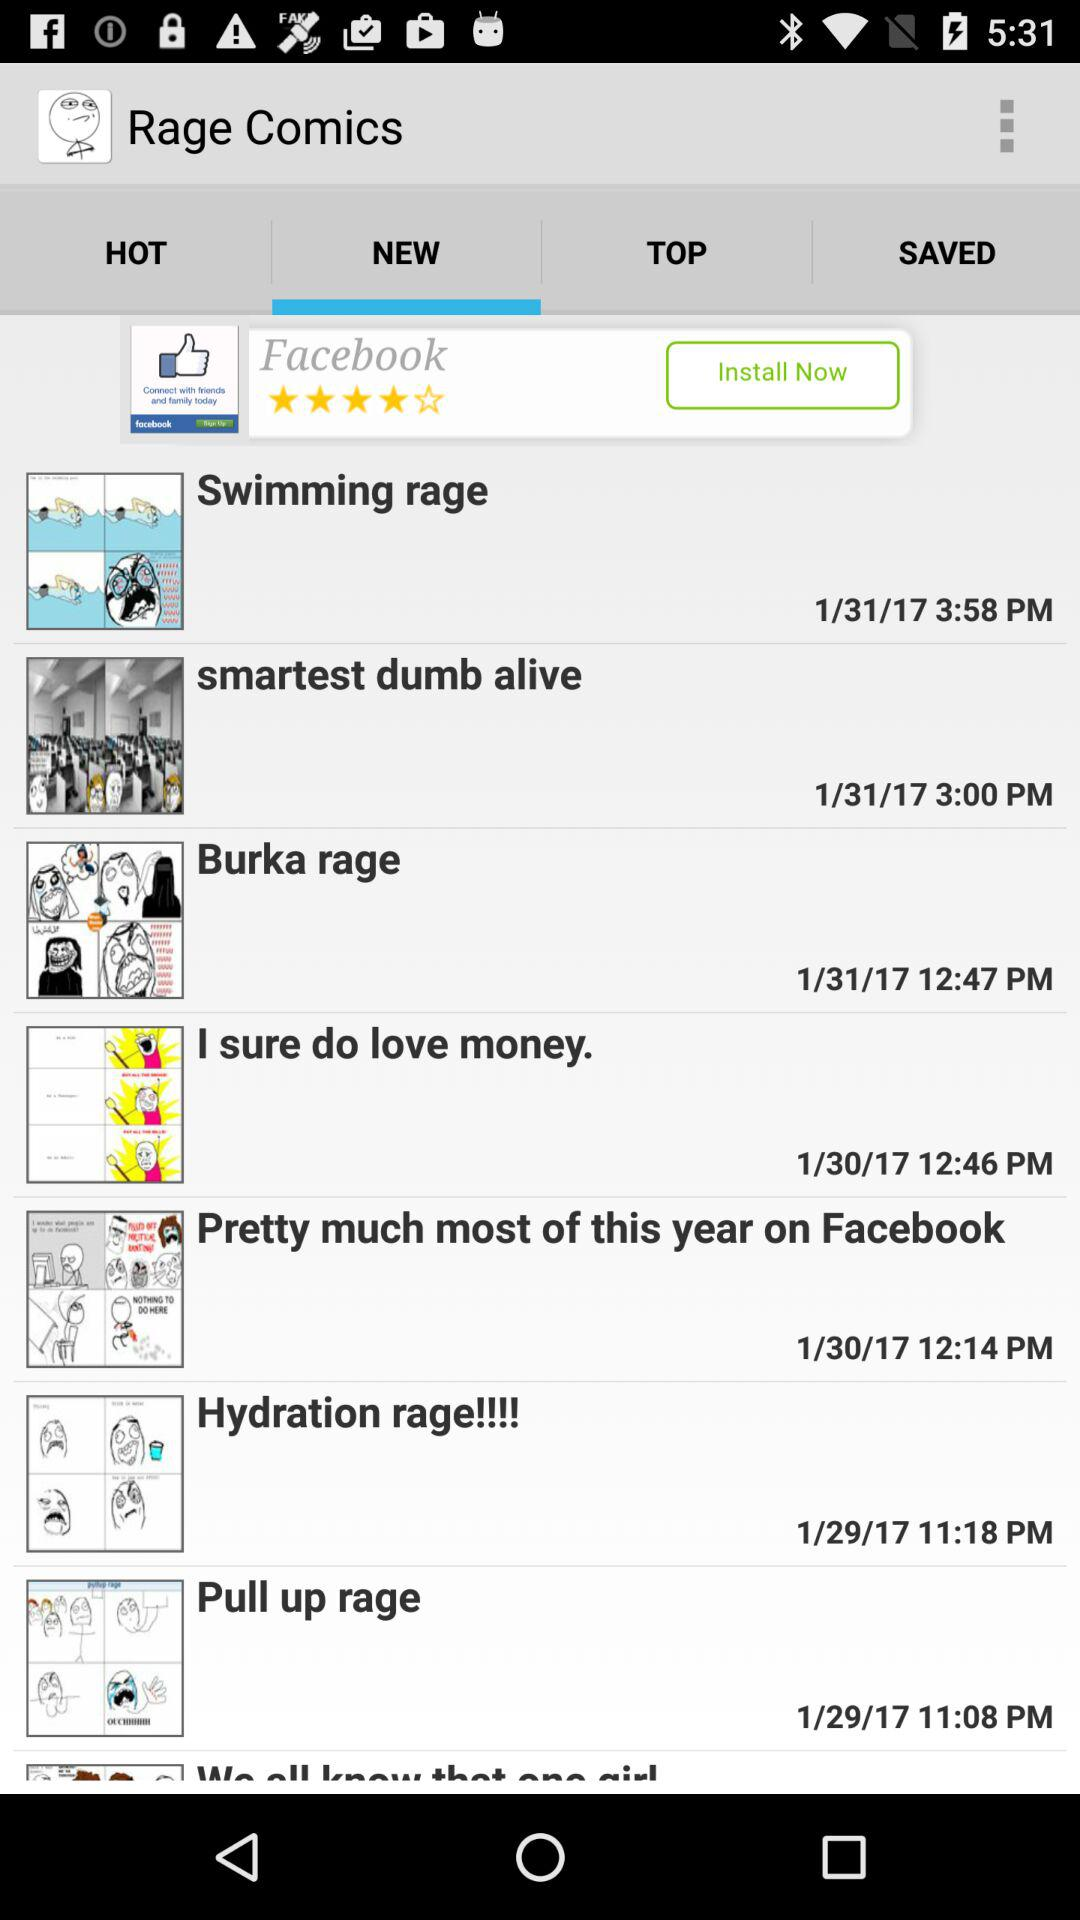What is the date and time of the Burka rage? The date and time of the Burka rage is "1/31/17" at 12:47 PM. 